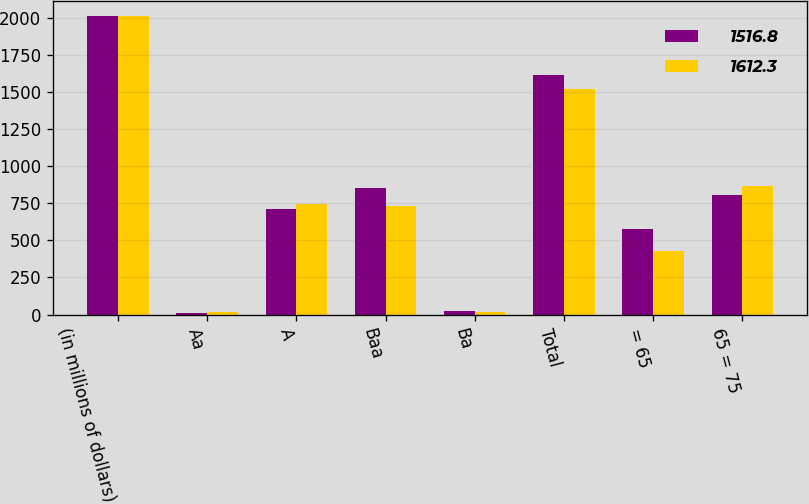Convert chart to OTSL. <chart><loc_0><loc_0><loc_500><loc_500><stacked_bar_chart><ecel><fcel>(in millions of dollars)<fcel>Aa<fcel>A<fcel>Baa<fcel>Ba<fcel>Total<fcel>= 65<fcel>65 = 75<nl><fcel>1516.8<fcel>2011<fcel>10.9<fcel>712.6<fcel>855<fcel>20.7<fcel>1612.3<fcel>578.4<fcel>802.3<nl><fcel>1612.3<fcel>2010<fcel>19<fcel>744.4<fcel>732.9<fcel>20.5<fcel>1516.8<fcel>425.3<fcel>869.2<nl></chart> 